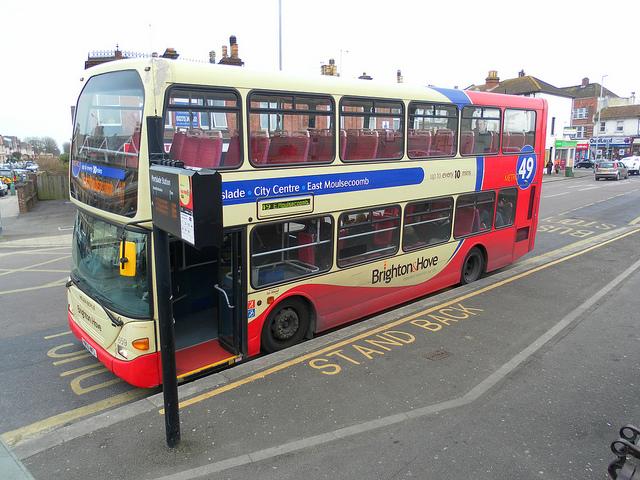Should you stand as close as possible to the solid yellow line?
Give a very brief answer. No. Are all the buses double Decker buses?
Short answer required. Yes. How many levels does the bus have?
Write a very short answer. 2. Are there any people getting on the bus?
Answer briefly. No. Are there empty seats on the upper deck?
Keep it brief. Yes. 